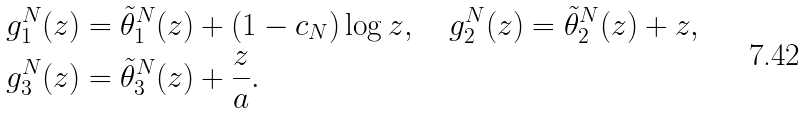<formula> <loc_0><loc_0><loc_500><loc_500>g _ { 1 } ^ { N } ( z ) & = \tilde { \theta } _ { 1 } ^ { N } ( z ) + ( 1 - c _ { N } ) \log z , \quad g _ { 2 } ^ { N } ( z ) = \tilde { \theta } _ { 2 } ^ { N } ( z ) + z , \\ g _ { 3 } ^ { N } ( z ) & = \tilde { \theta } _ { 3 } ^ { N } ( z ) + \frac { z } { a } .</formula> 